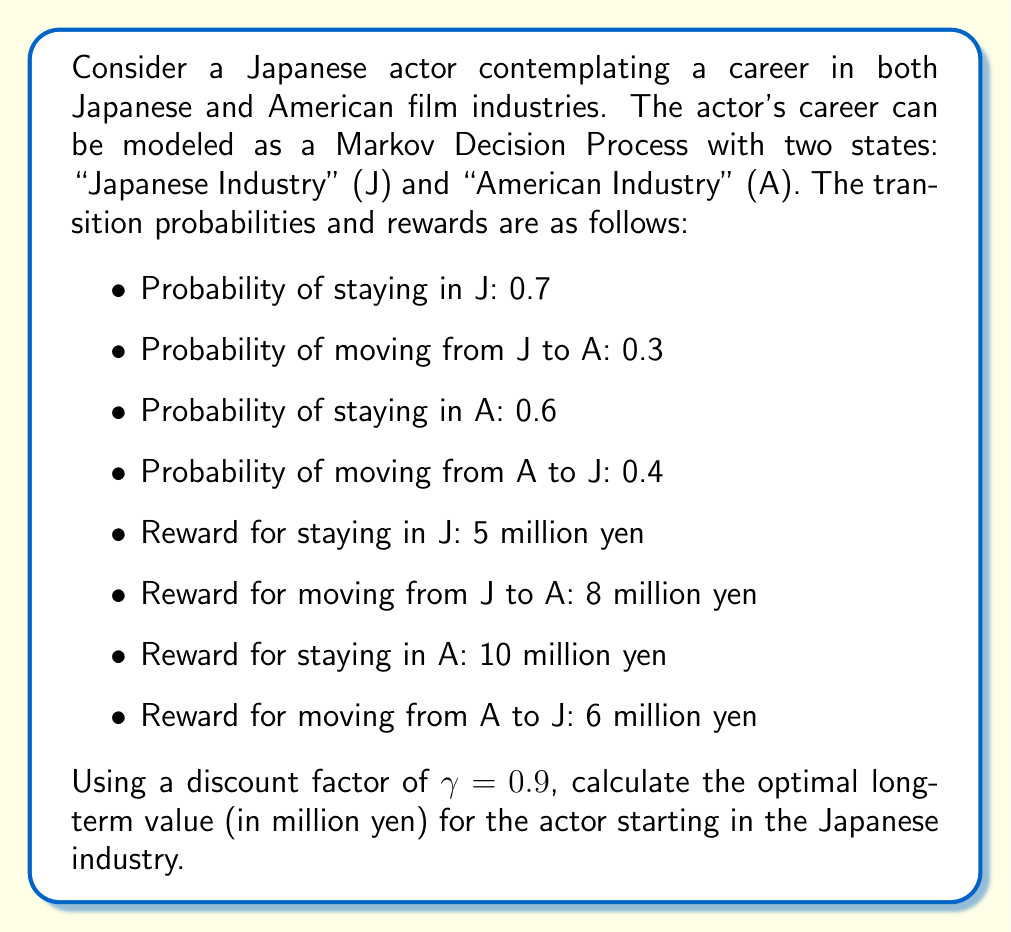What is the answer to this math problem? To solve this problem, we'll use the Bellman equation for the optimal value function in a Markov Decision Process:

$$V^*(s) = \max_a \left(R(s,a) + \gamma \sum_{s'} P(s'|s,a)V^*(s')\right)$$

Let $V_J$ and $V_A$ be the optimal values for starting in the Japanese and American industries, respectively. We can write two equations:

1. For the Japanese industry (J):
$$V_J = \max \left(5 + 0.9(0.7V_J + 0.3V_A), 8 + 0.9(0.6V_A + 0.4V_J)\right)$$

2. For the American industry (A):
$$V_A = \max \left(10 + 0.9(0.6V_A + 0.4V_J), 6 + 0.9(0.7V_J + 0.3V_A)\right)$$

To solve this system of equations, we'll use the fact that at optimality, the actor will choose the action that maximizes the value. Let's assume that staying in each industry is optimal (we'll verify this later):

$$V_J = 5 + 0.9(0.7V_J + 0.3V_A)$$
$$V_A = 10 + 0.9(0.6V_A + 0.4V_J)$$

Now we have a system of two linear equations with two unknowns. Let's solve it:

1. From the first equation:
   $V_J = 5 + 0.63V_J + 0.27V_A$
   $0.37V_J = 5 + 0.27V_A$
   $V_J = 13.51 + 0.73V_A$

2. Substitute this into the second equation:
   $V_A = 10 + 0.54V_A + 0.36(13.51 + 0.73V_A)$
   $V_A = 10 + 0.54V_A + 4.86 + 0.2628V_A$
   $0.1972V_A = 14.86$
   $V_A = 75.35$

3. Now we can find $V_J$:
   $V_J = 13.51 + 0.73(75.35) = 68.52$

To verify our assumption, let's check if staying in each industry is indeed optimal:

For J: $5 + 0.9(0.7(68.52) + 0.3(75.35)) = 68.52$
       $8 + 0.9(0.6(75.35) + 0.4(68.52)) = 67.89$

For A: $10 + 0.9(0.6(75.35) + 0.4(68.52)) = 75.35$
       $6 + 0.9(0.7(68.52) + 0.3(75.35)) = 71.52$

Our assumption is correct, as staying in each industry yields higher values.
Answer: The optimal long-term value for the actor starting in the Japanese industry is approximately 68.52 million yen. 